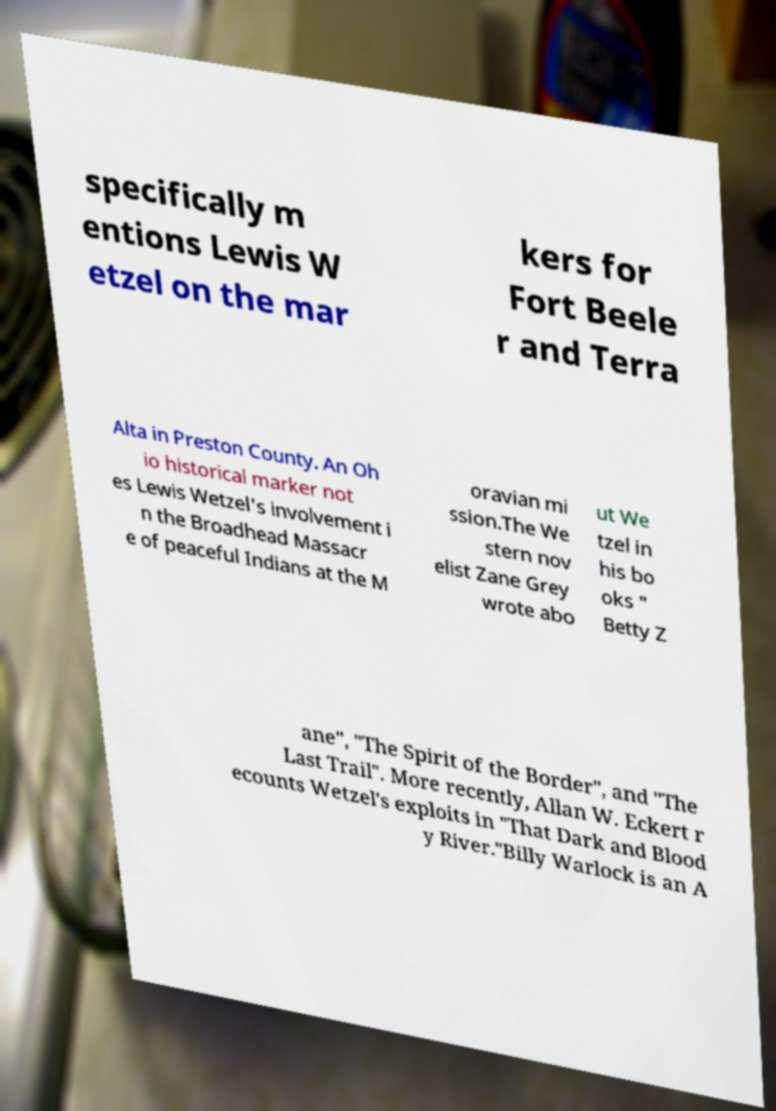Could you assist in decoding the text presented in this image and type it out clearly? specifically m entions Lewis W etzel on the mar kers for Fort Beele r and Terra Alta in Preston County. An Oh io historical marker not es Lewis Wetzel's involvement i n the Broadhead Massacr e of peaceful Indians at the M oravian mi ssion.The We stern nov elist Zane Grey wrote abo ut We tzel in his bo oks " Betty Z ane", "The Spirit of the Border", and "The Last Trail". More recently, Allan W. Eckert r ecounts Wetzel's exploits in "That Dark and Blood y River."Billy Warlock is an A 